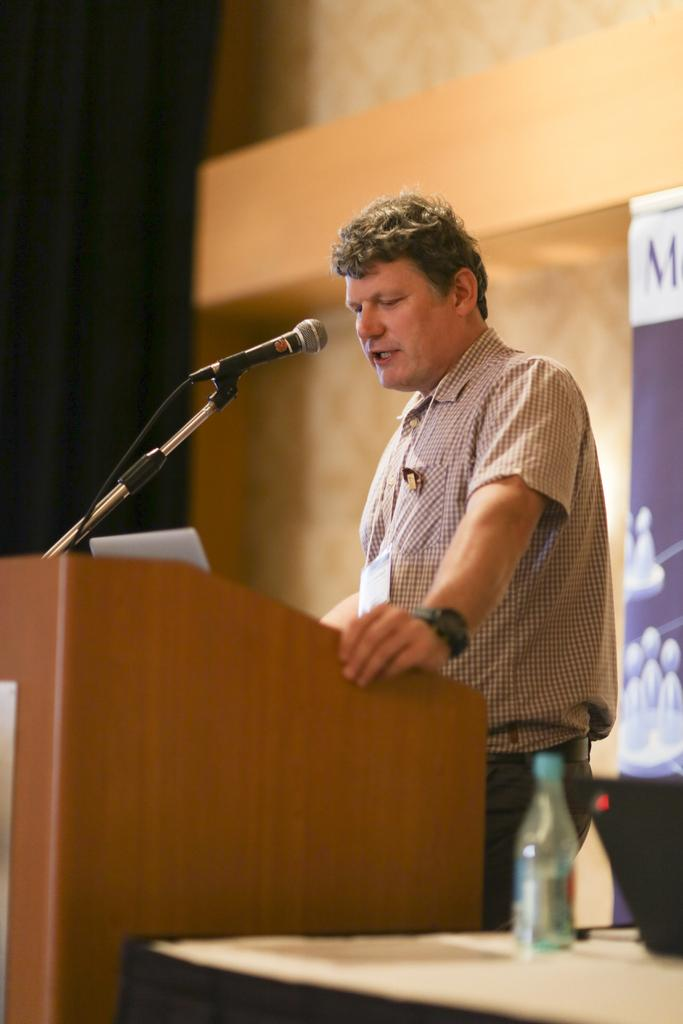What is the man in the image doing? There is a man standing in the image, but his activity is not specified. What object is present in the image that is typically used for amplifying sound? There is a microphone in the image. What can be seen on the table in the image? There is a bottle on a table in the image. What is the color and purpose of the curtain in the background of the image? There is a black curtain in the background of the image, but its purpose is not specified. What type of butter is being used to make the snow in the image? There is no butter or snow present in the image. 